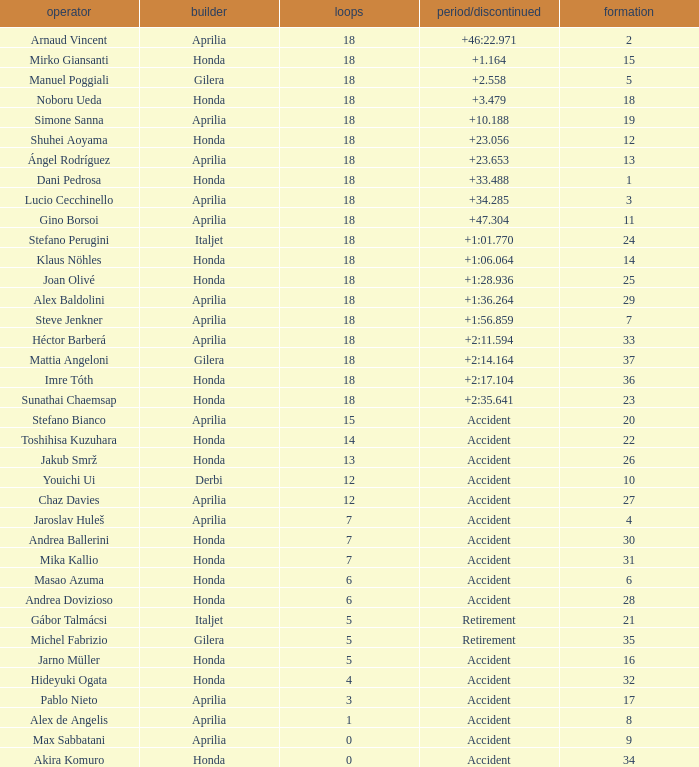What is the time/retired of the honda manufacturer with a grid less than 26, 18 laps, and joan olivé as the rider? +1:28.936. 